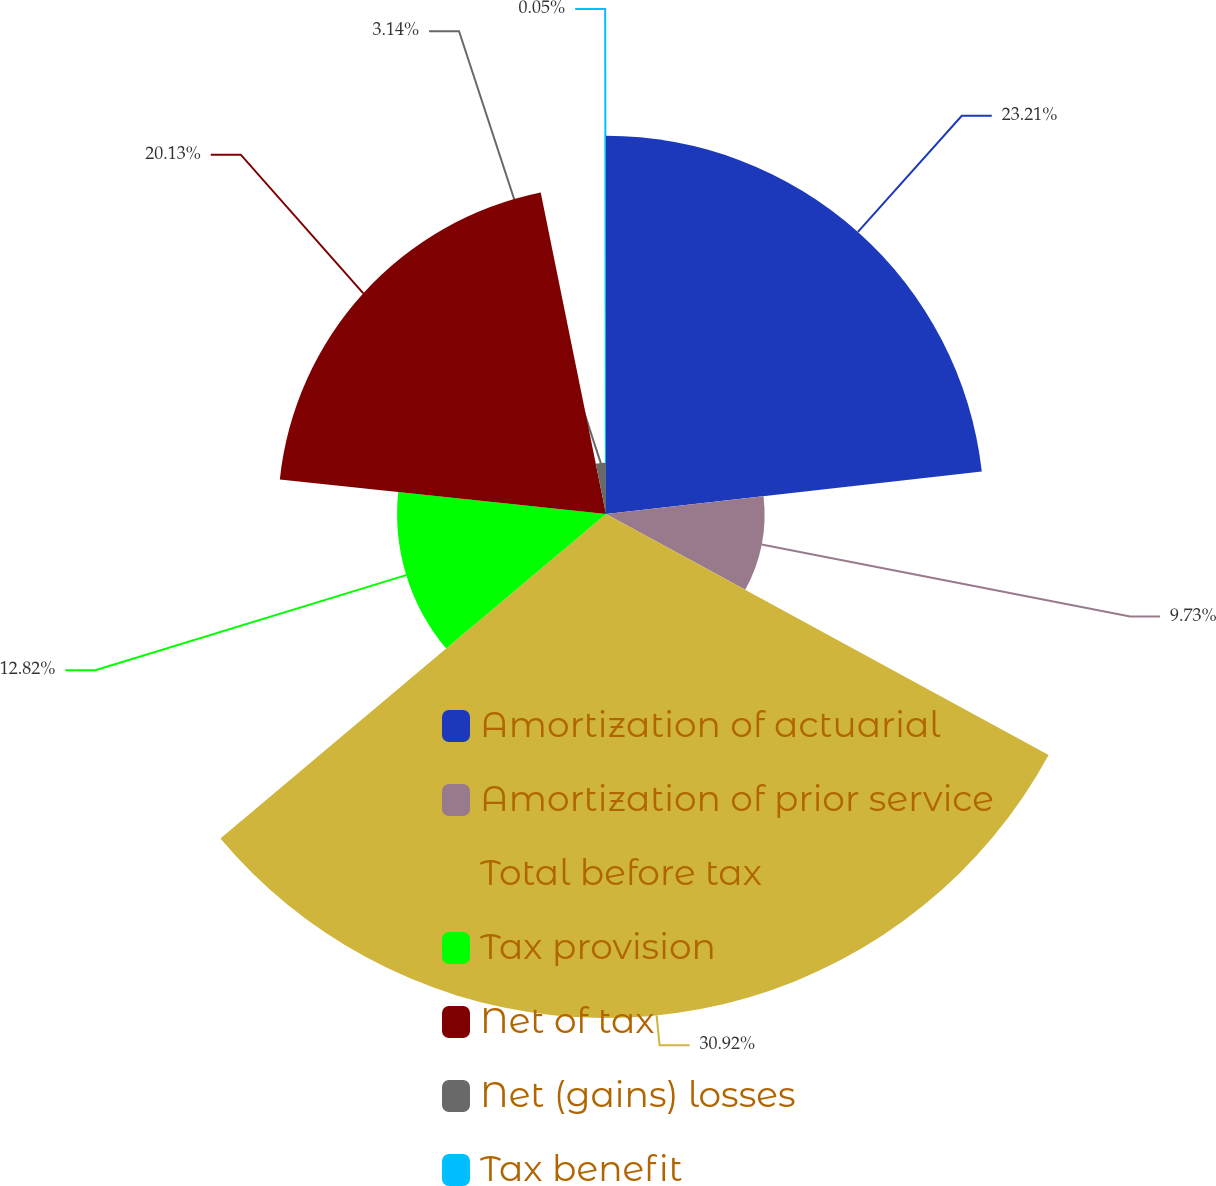Convert chart to OTSL. <chart><loc_0><loc_0><loc_500><loc_500><pie_chart><fcel>Amortization of actuarial<fcel>Amortization of prior service<fcel>Total before tax<fcel>Tax provision<fcel>Net of tax<fcel>Net (gains) losses<fcel>Tax benefit<nl><fcel>23.21%<fcel>9.73%<fcel>30.93%<fcel>12.82%<fcel>20.13%<fcel>3.14%<fcel>0.05%<nl></chart> 